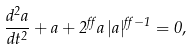Convert formula to latex. <formula><loc_0><loc_0><loc_500><loc_500>\frac { d ^ { 2 } a } { d t ^ { 2 } } + a + 2 ^ { \alpha } a \, | a | ^ { \alpha - 1 } = 0 ,</formula> 